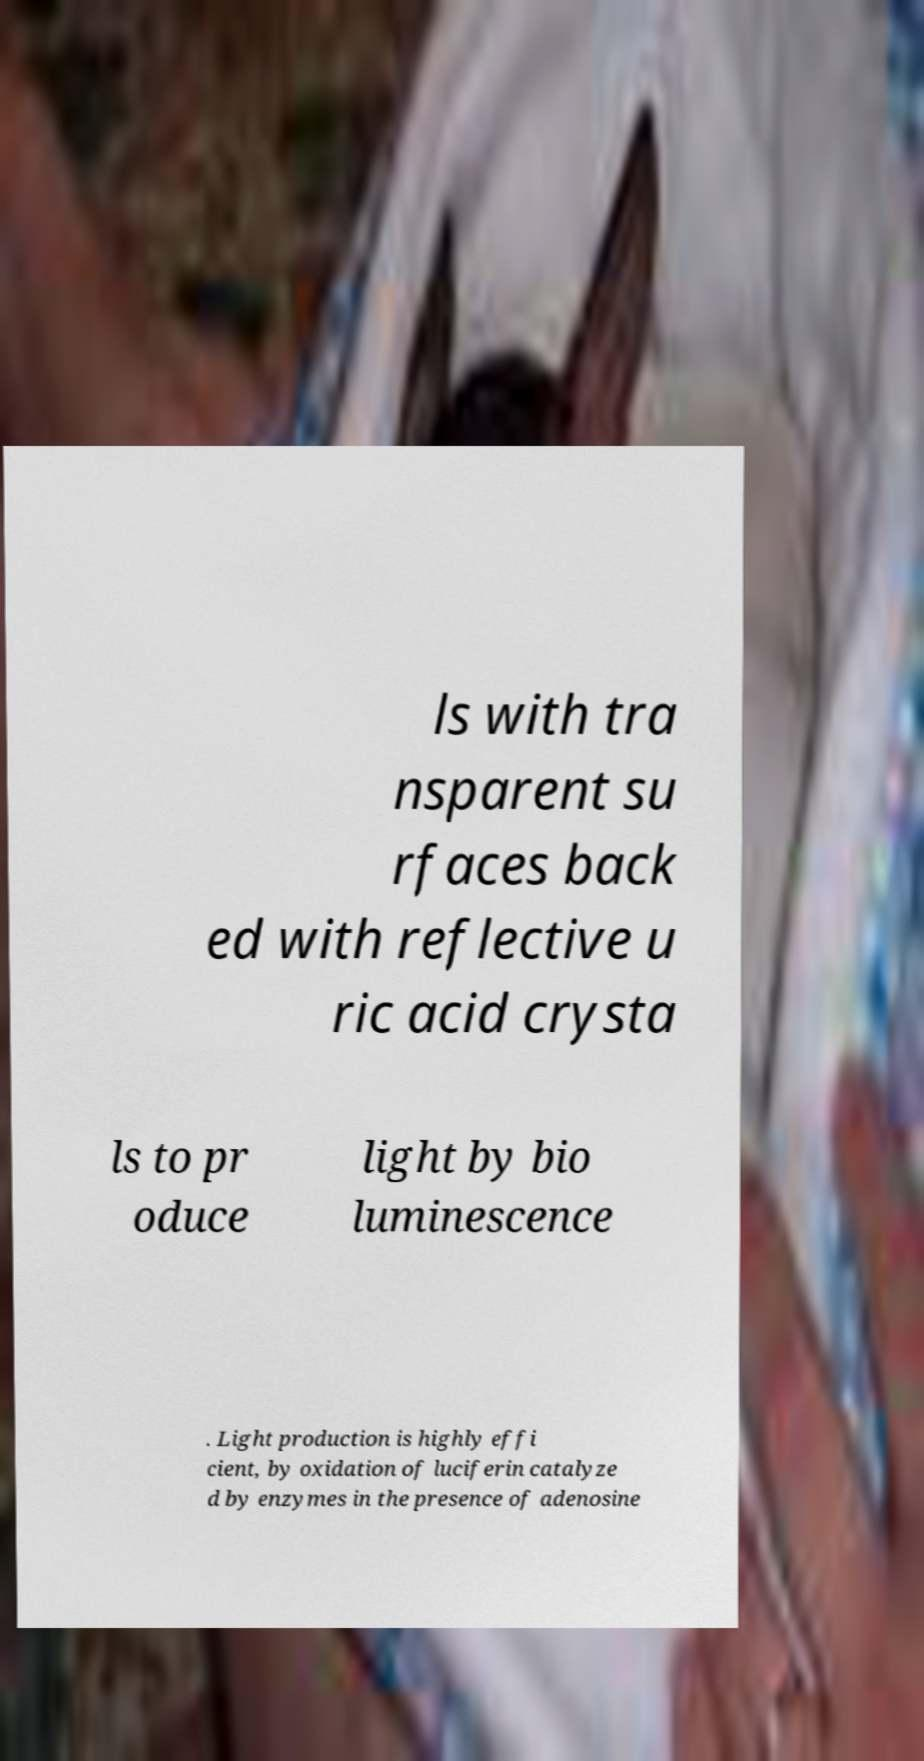Could you extract and type out the text from this image? ls with tra nsparent su rfaces back ed with reflective u ric acid crysta ls to pr oduce light by bio luminescence . Light production is highly effi cient, by oxidation of luciferin catalyze d by enzymes in the presence of adenosine 